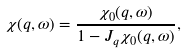<formula> <loc_0><loc_0><loc_500><loc_500>\chi ( { q } , \omega ) = \frac { \chi _ { 0 } ( { q } , \omega ) } { 1 - J _ { q } \chi _ { 0 } ( { q } , \omega ) } ,</formula> 